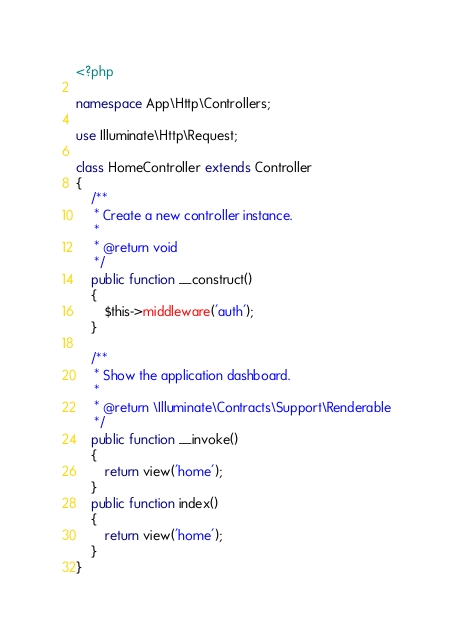Convert code to text. <code><loc_0><loc_0><loc_500><loc_500><_PHP_><?php

namespace App\Http\Controllers;

use Illuminate\Http\Request;

class HomeController extends Controller
{
    /**
     * Create a new controller instance.
     *
     * @return void
     */
    public function __construct()
    {
        $this->middleware('auth');
    }

    /**
     * Show the application dashboard.
     *
     * @return \Illuminate\Contracts\Support\Renderable
     */
    public function __invoke()
    {
        return view('home');
    }
    public function index()
    {
        return view('home');
    }
}
</code> 